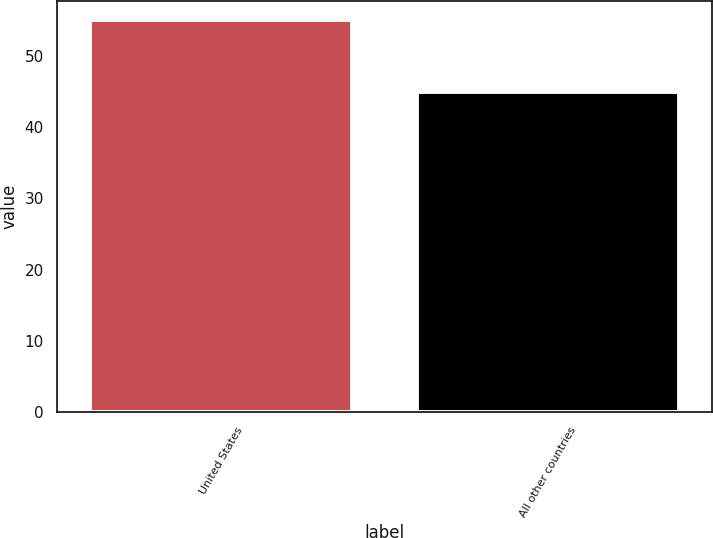<chart> <loc_0><loc_0><loc_500><loc_500><bar_chart><fcel>United States<fcel>All other countries<nl><fcel>55<fcel>45<nl></chart> 